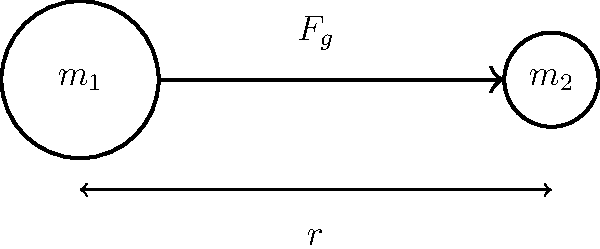Two spherical objects with masses $m_1 = 5 \times 10^{24}$ kg and $m_2 = 7 \times 10^{22}$ kg are separated by a distance of $4 \times 10^8$ m. Calculate the gravitational force between these two objects. Use the gravitational constant $G = 6.67 \times 10^{-11}$ N⋅m²/kg². Express your answer in scientific notation with two decimal places. To calculate the gravitational force between two objects, we use Newton's law of universal gravitation:

$$F_g = G \frac{m_1 m_2}{r^2}$$

Where:
$F_g$ is the gravitational force (N)
$G$ is the gravitational constant ($6.67 \times 10^{-11}$ N⋅m²/kg²)
$m_1$ and $m_2$ are the masses of the two objects (kg)
$r$ is the distance between the centers of the objects (m)

Let's substitute the given values:

$G = 6.67 \times 10^{-11}$ N⋅m²/kg²
$m_1 = 5 \times 10^{24}$ kg
$m_2 = 7 \times 10^{22}$ kg
$r = 4 \times 10^8$ m

Now, let's calculate:

$$\begin{align*}
F_g &= (6.67 \times 10^{-11}) \frac{(5 \times 10^{24})(7 \times 10^{22})}{(4 \times 10^8)^2} \\[10pt]
&= (6.67 \times 10^{-11}) \frac{35 \times 10^{46}}{16 \times 10^{16}} \\[10pt]
&= (6.67 \times 10^{-11})(2.1875 \times 10^{30}) \\[10pt]
&= 1.459125 \times 10^{20} \text{ N}
\end{align*}$$

Rounding to two decimal places in scientific notation:

$$F_g = 1.46 \times 10^{20} \text{ N}$$
Answer: $1.46 \times 10^{20}$ N 